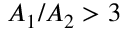<formula> <loc_0><loc_0><loc_500><loc_500>A _ { 1 } / A _ { 2 } > 3</formula> 